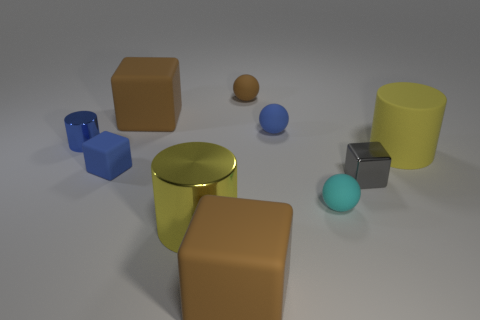Subtract all blocks. How many objects are left? 6 Add 7 small gray shiny objects. How many small gray shiny objects are left? 8 Add 2 small shiny things. How many small shiny things exist? 4 Subtract 0 red spheres. How many objects are left? 10 Subtract all small cyan spheres. Subtract all small blue matte balls. How many objects are left? 8 